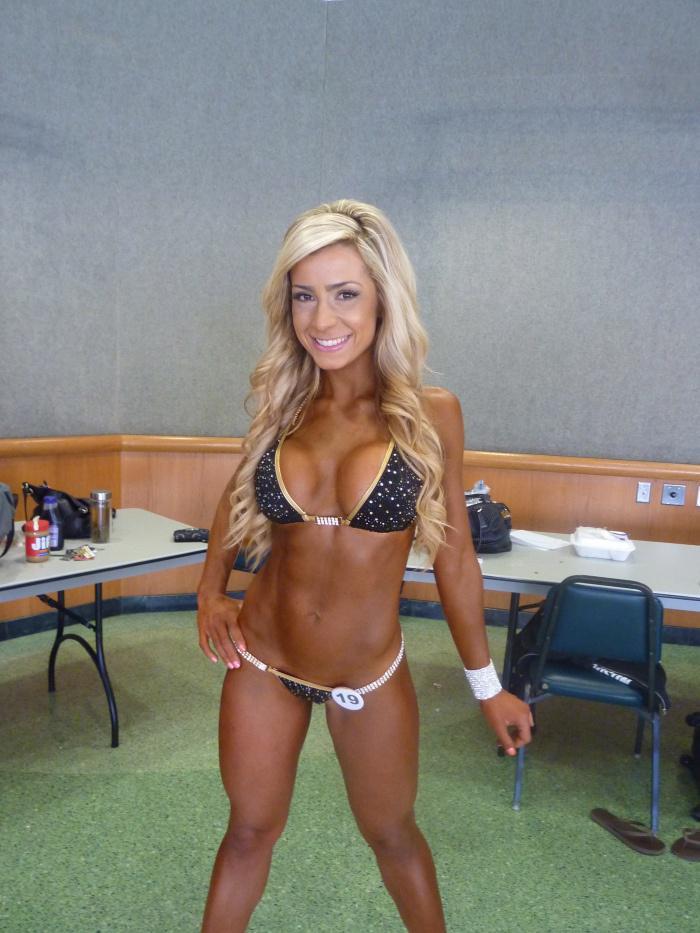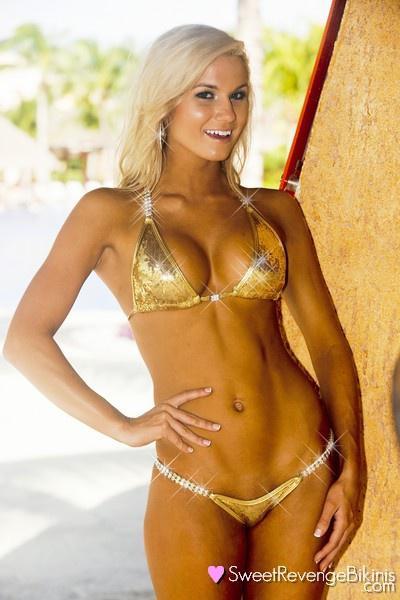The first image is the image on the left, the second image is the image on the right. Considering the images on both sides, is "The left and right image contains the same number of bikinis with one being gold." valid? Answer yes or no. Yes. The first image is the image on the left, the second image is the image on the right. For the images shown, is this caption "An image shows a woman wearing a shiny gold bikini and posing with her arm on her hip." true? Answer yes or no. Yes. 